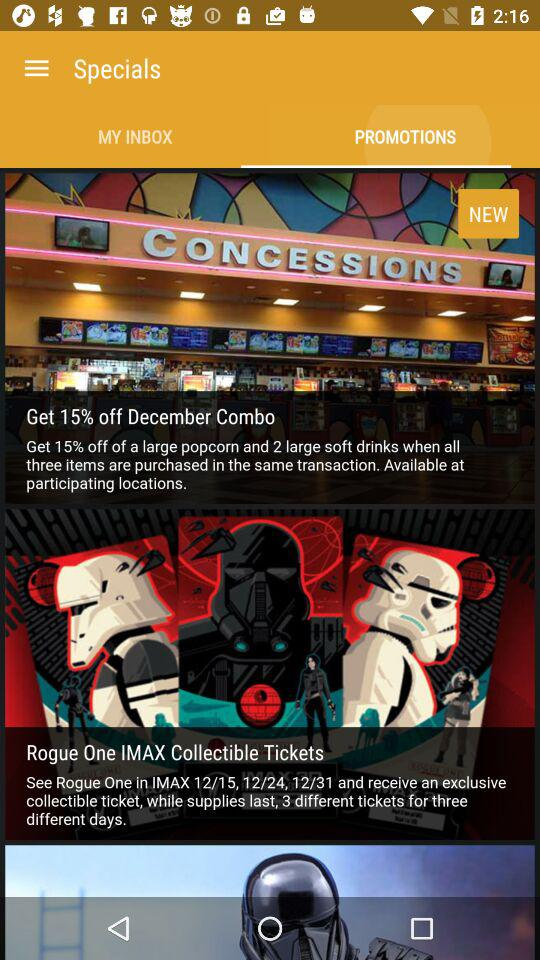Which option is selected in "Specials"? The selected option in "Specials" is "PROMOTIONS". 